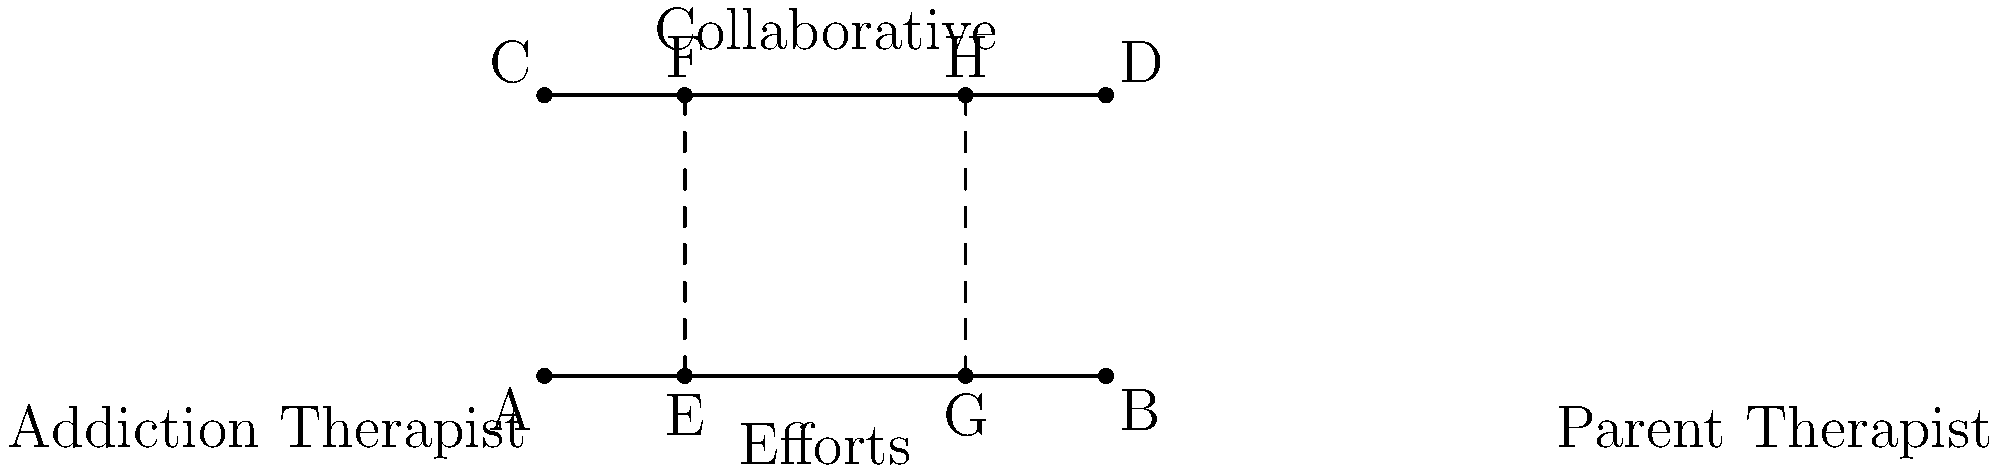In the diagram representing collaborative efforts between addiction and parent therapists, parallel lines AB and CD represent their respective approaches. If line segments EF and GH represent specific collaborative interventions, and $\overline{AE} : \overline{EB} = 1 : 3$, what is the ratio of $\overline{CG} : \overline{GD}$? To solve this problem, we'll use the properties of parallel lines and the concept of similarity:

1) First, note that lines AB and CD are parallel, representing the therapists' approaches.

2) EF and GH are transversals cutting these parallel lines.

3) When a line is drawn parallel to one side of a triangle, it divides the other two sides in the same ratio. This principle applies to parallel lines as well.

4) We're given that $\overline{AE} : \overline{EB} = 1 : 3$

5) Due to the properties of parallel lines, this same ratio will be maintained on line CD.

6) Therefore, $\overline{CG} : \overline{GD}$ must also equal $1 : 3$

This ratio represents how the collaborative interventions (EF and GH) interact with both therapists' approaches in a proportional manner, emphasizing the importance of coordinated efforts in addiction treatment.
Answer: $1 : 3$ 